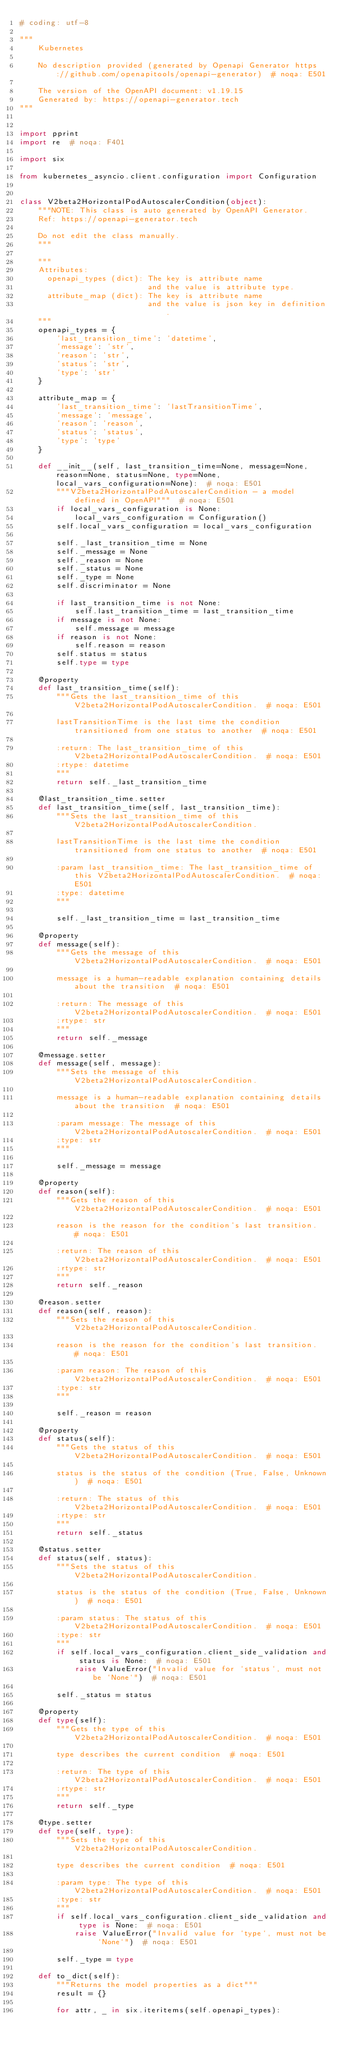<code> <loc_0><loc_0><loc_500><loc_500><_Python_># coding: utf-8

"""
    Kubernetes

    No description provided (generated by Openapi Generator https://github.com/openapitools/openapi-generator)  # noqa: E501

    The version of the OpenAPI document: v1.19.15
    Generated by: https://openapi-generator.tech
"""


import pprint
import re  # noqa: F401

import six

from kubernetes_asyncio.client.configuration import Configuration


class V2beta2HorizontalPodAutoscalerCondition(object):
    """NOTE: This class is auto generated by OpenAPI Generator.
    Ref: https://openapi-generator.tech

    Do not edit the class manually.
    """

    """
    Attributes:
      openapi_types (dict): The key is attribute name
                            and the value is attribute type.
      attribute_map (dict): The key is attribute name
                            and the value is json key in definition.
    """
    openapi_types = {
        'last_transition_time': 'datetime',
        'message': 'str',
        'reason': 'str',
        'status': 'str',
        'type': 'str'
    }

    attribute_map = {
        'last_transition_time': 'lastTransitionTime',
        'message': 'message',
        'reason': 'reason',
        'status': 'status',
        'type': 'type'
    }

    def __init__(self, last_transition_time=None, message=None, reason=None, status=None, type=None, local_vars_configuration=None):  # noqa: E501
        """V2beta2HorizontalPodAutoscalerCondition - a model defined in OpenAPI"""  # noqa: E501
        if local_vars_configuration is None:
            local_vars_configuration = Configuration()
        self.local_vars_configuration = local_vars_configuration

        self._last_transition_time = None
        self._message = None
        self._reason = None
        self._status = None
        self._type = None
        self.discriminator = None

        if last_transition_time is not None:
            self.last_transition_time = last_transition_time
        if message is not None:
            self.message = message
        if reason is not None:
            self.reason = reason
        self.status = status
        self.type = type

    @property
    def last_transition_time(self):
        """Gets the last_transition_time of this V2beta2HorizontalPodAutoscalerCondition.  # noqa: E501

        lastTransitionTime is the last time the condition transitioned from one status to another  # noqa: E501

        :return: The last_transition_time of this V2beta2HorizontalPodAutoscalerCondition.  # noqa: E501
        :rtype: datetime
        """
        return self._last_transition_time

    @last_transition_time.setter
    def last_transition_time(self, last_transition_time):
        """Sets the last_transition_time of this V2beta2HorizontalPodAutoscalerCondition.

        lastTransitionTime is the last time the condition transitioned from one status to another  # noqa: E501

        :param last_transition_time: The last_transition_time of this V2beta2HorizontalPodAutoscalerCondition.  # noqa: E501
        :type: datetime
        """

        self._last_transition_time = last_transition_time

    @property
    def message(self):
        """Gets the message of this V2beta2HorizontalPodAutoscalerCondition.  # noqa: E501

        message is a human-readable explanation containing details about the transition  # noqa: E501

        :return: The message of this V2beta2HorizontalPodAutoscalerCondition.  # noqa: E501
        :rtype: str
        """
        return self._message

    @message.setter
    def message(self, message):
        """Sets the message of this V2beta2HorizontalPodAutoscalerCondition.

        message is a human-readable explanation containing details about the transition  # noqa: E501

        :param message: The message of this V2beta2HorizontalPodAutoscalerCondition.  # noqa: E501
        :type: str
        """

        self._message = message

    @property
    def reason(self):
        """Gets the reason of this V2beta2HorizontalPodAutoscalerCondition.  # noqa: E501

        reason is the reason for the condition's last transition.  # noqa: E501

        :return: The reason of this V2beta2HorizontalPodAutoscalerCondition.  # noqa: E501
        :rtype: str
        """
        return self._reason

    @reason.setter
    def reason(self, reason):
        """Sets the reason of this V2beta2HorizontalPodAutoscalerCondition.

        reason is the reason for the condition's last transition.  # noqa: E501

        :param reason: The reason of this V2beta2HorizontalPodAutoscalerCondition.  # noqa: E501
        :type: str
        """

        self._reason = reason

    @property
    def status(self):
        """Gets the status of this V2beta2HorizontalPodAutoscalerCondition.  # noqa: E501

        status is the status of the condition (True, False, Unknown)  # noqa: E501

        :return: The status of this V2beta2HorizontalPodAutoscalerCondition.  # noqa: E501
        :rtype: str
        """
        return self._status

    @status.setter
    def status(self, status):
        """Sets the status of this V2beta2HorizontalPodAutoscalerCondition.

        status is the status of the condition (True, False, Unknown)  # noqa: E501

        :param status: The status of this V2beta2HorizontalPodAutoscalerCondition.  # noqa: E501
        :type: str
        """
        if self.local_vars_configuration.client_side_validation and status is None:  # noqa: E501
            raise ValueError("Invalid value for `status`, must not be `None`")  # noqa: E501

        self._status = status

    @property
    def type(self):
        """Gets the type of this V2beta2HorizontalPodAutoscalerCondition.  # noqa: E501

        type describes the current condition  # noqa: E501

        :return: The type of this V2beta2HorizontalPodAutoscalerCondition.  # noqa: E501
        :rtype: str
        """
        return self._type

    @type.setter
    def type(self, type):
        """Sets the type of this V2beta2HorizontalPodAutoscalerCondition.

        type describes the current condition  # noqa: E501

        :param type: The type of this V2beta2HorizontalPodAutoscalerCondition.  # noqa: E501
        :type: str
        """
        if self.local_vars_configuration.client_side_validation and type is None:  # noqa: E501
            raise ValueError("Invalid value for `type`, must not be `None`")  # noqa: E501

        self._type = type

    def to_dict(self):
        """Returns the model properties as a dict"""
        result = {}

        for attr, _ in six.iteritems(self.openapi_types):</code> 